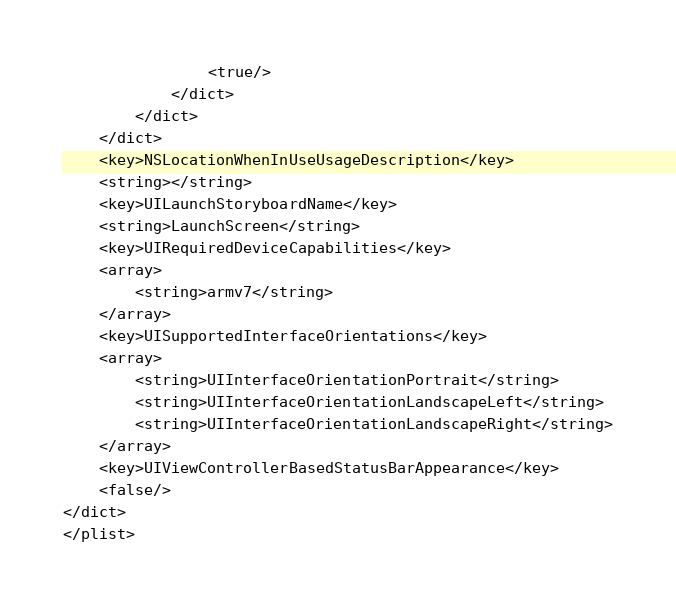<code> <loc_0><loc_0><loc_500><loc_500><_XML_>				<true/>
			</dict>
		</dict>
	</dict>
	<key>NSLocationWhenInUseUsageDescription</key>
	<string></string>
	<key>UILaunchStoryboardName</key>
	<string>LaunchScreen</string>
	<key>UIRequiredDeviceCapabilities</key>
	<array>
		<string>armv7</string>
	</array>
	<key>UISupportedInterfaceOrientations</key>
	<array>
		<string>UIInterfaceOrientationPortrait</string>
		<string>UIInterfaceOrientationLandscapeLeft</string>
		<string>UIInterfaceOrientationLandscapeRight</string>
	</array>
	<key>UIViewControllerBasedStatusBarAppearance</key>
	<false/>
</dict>
</plist>
</code> 